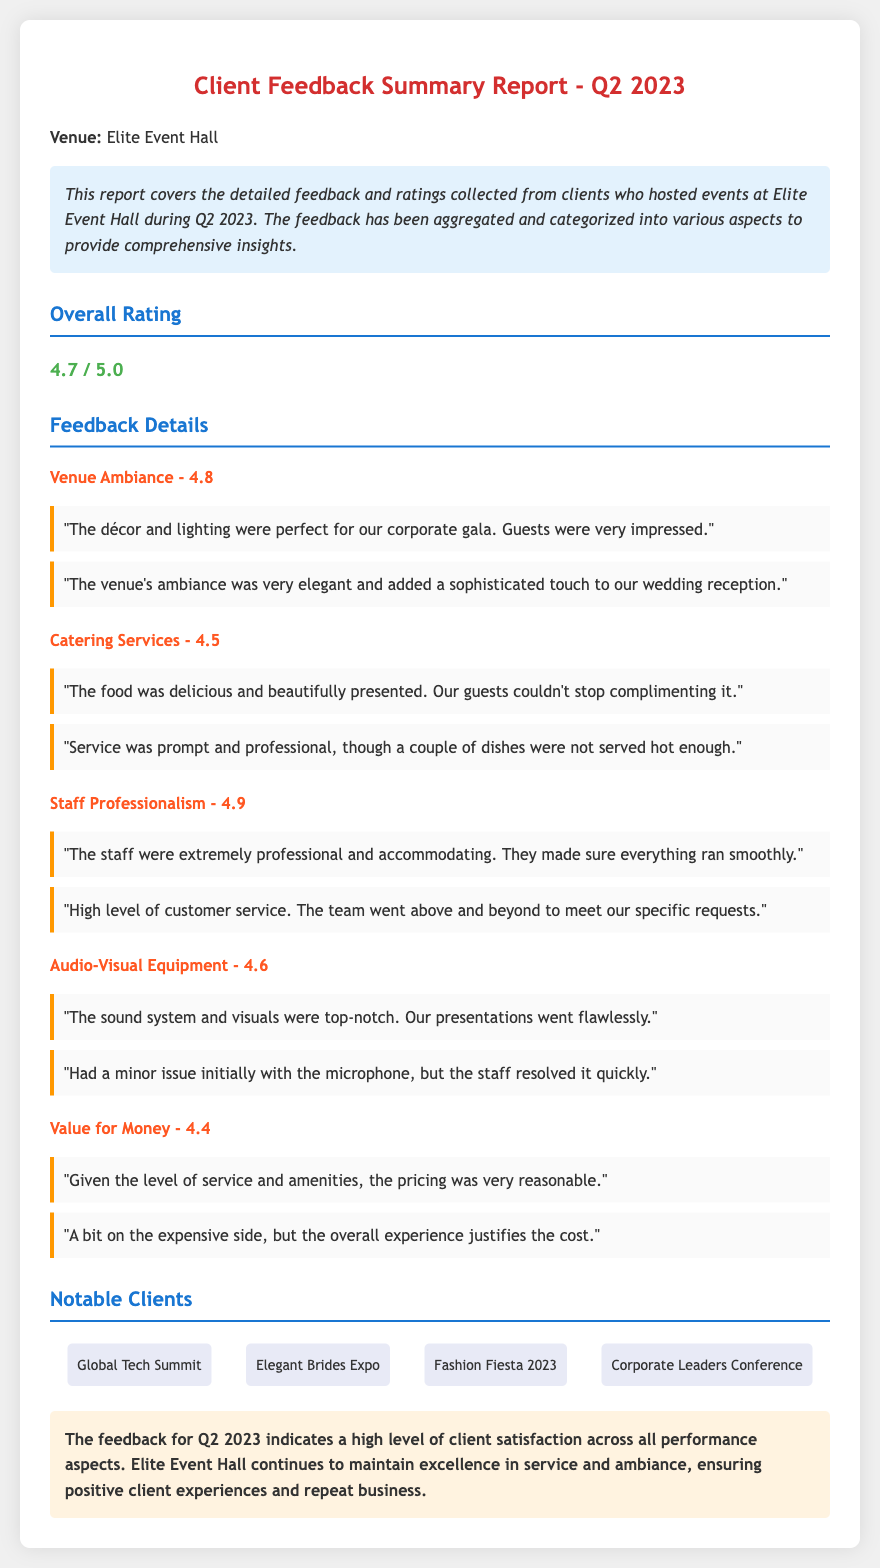what is the overall rating for Q2 2023? The overall rating is mentioned prominently in the report as a summary of client feedback.
Answer: 4.7 / 5.0 what rating did the venue ambiance receive? The venue ambiance is one of the specific areas evaluated in the feedback, showing its performance rating.
Answer: 4.8 who hosted the Global Tech Summit? This is a notable client listed in the report, showcasing their association with Elite Event Hall.
Answer: Global Tech Summit what was a common compliment about the catering services? Compliments are found in the comments section related to specific aspects of client feedback.
Answer: Delicious and beautifully presented how did clients rate staff professionalism? The staff professionalism is another area that received a specific rating based on client feedback.
Answer: 4.9 what is noted as a minor issue with the audio-visual equipment? This issue pertains to client experiences during their events, highlighting areas for potential improvement.
Answer: Minor issue initially with the microphone which aspect received the lowest rating in the feedback? The ratings for various aspects can be compared to identify which one received the least satisfaction.
Answer: Value for Money - 4.4 how many notable clients are listed in the report? The document mentions notable clients in a specific section, indicating the breadth of Elite Event Hall's client base.
Answer: Four 